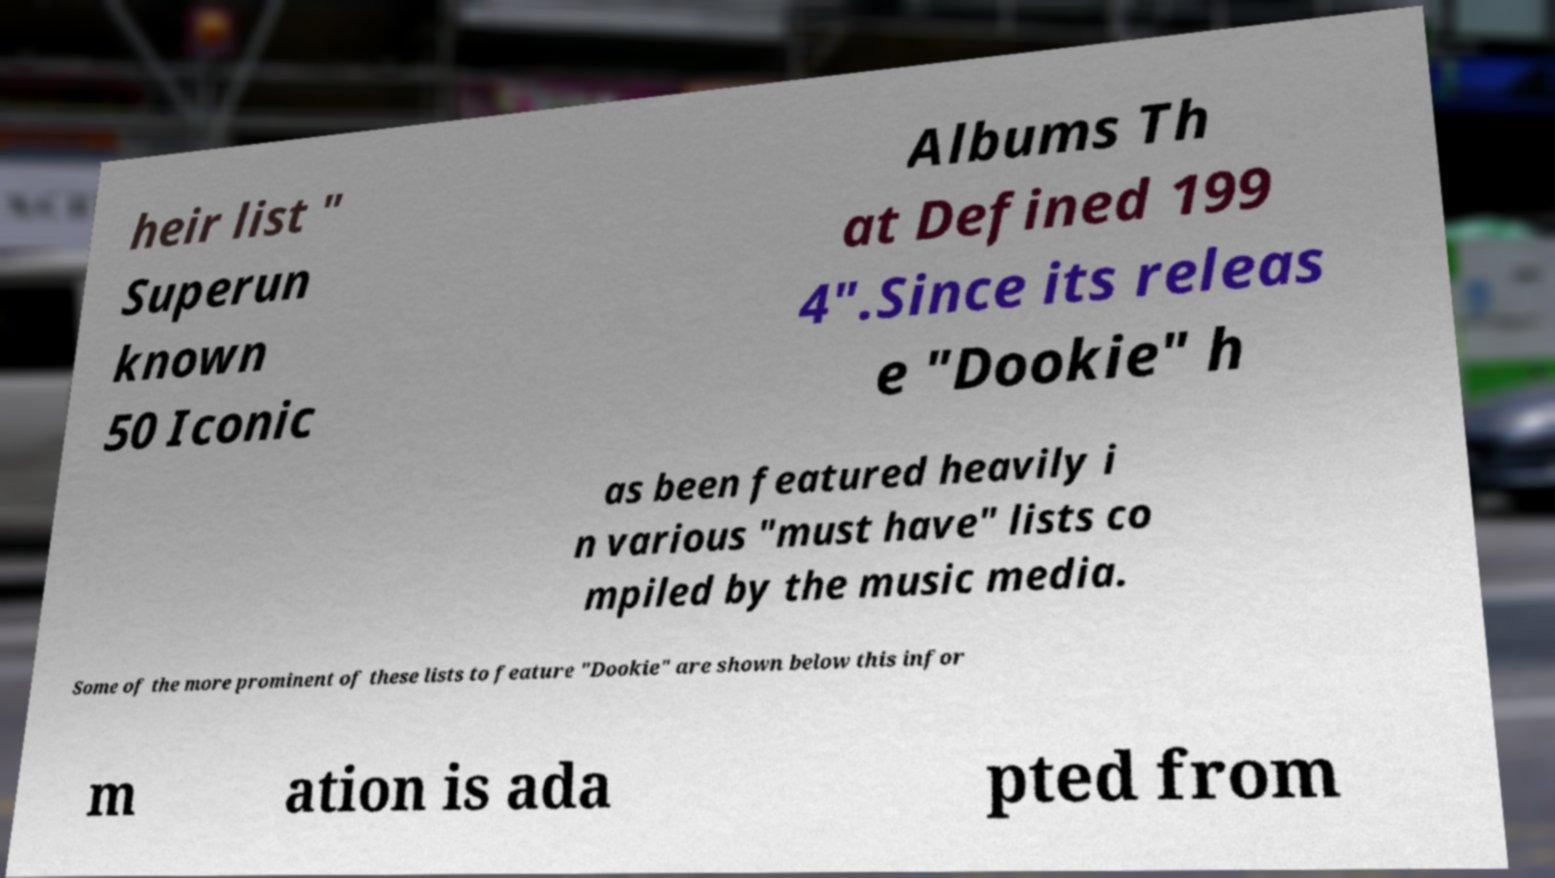I need the written content from this picture converted into text. Can you do that? heir list " Superun known 50 Iconic Albums Th at Defined 199 4".Since its releas e "Dookie" h as been featured heavily i n various "must have" lists co mpiled by the music media. Some of the more prominent of these lists to feature "Dookie" are shown below this infor m ation is ada pted from 